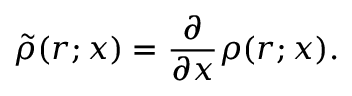Convert formula to latex. <formula><loc_0><loc_0><loc_500><loc_500>\tilde { \rho } ( r ; x ) = \frac { \partial } { \partial x } \rho ( r ; x ) .</formula> 